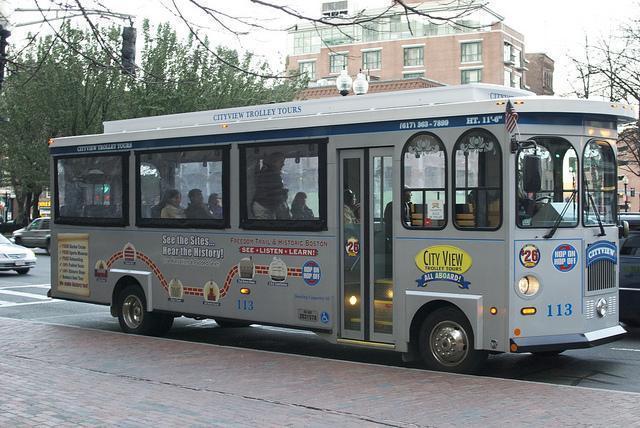What is the bus primarily used for?
From the following set of four choices, select the accurate answer to respond to the question.
Options: Tours, racing, shipping, school. Tours. 